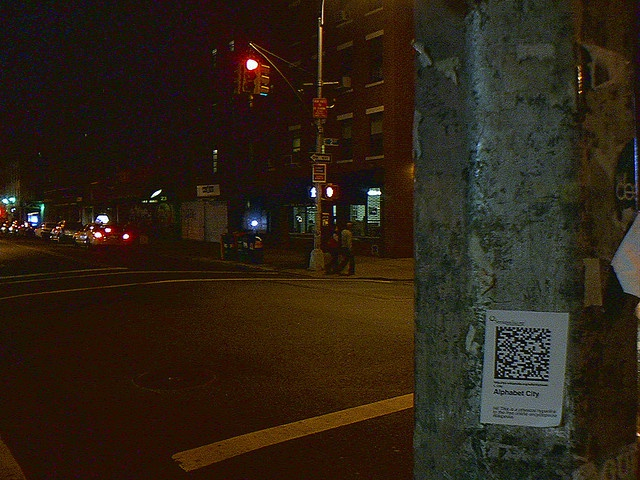Describe the objects in this image and their specific colors. I can see car in maroon, black, and white tones, traffic light in maroon, black, and white tones, people in maroon, black, and olive tones, car in maroon, black, olive, and gray tones, and people in maroon, black, darkgreen, and navy tones in this image. 